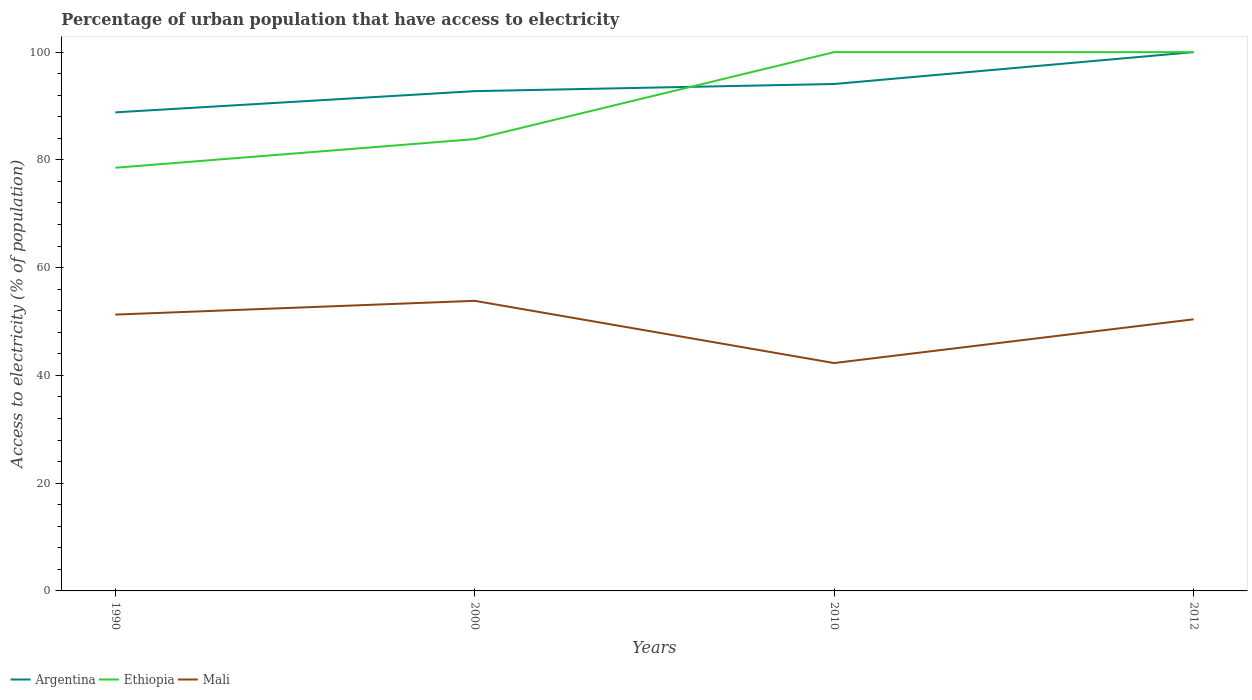Across all years, what is the maximum percentage of urban population that have access to electricity in Mali?
Provide a short and direct response. 42.29. What is the total percentage of urban population that have access to electricity in Argentina in the graph?
Give a very brief answer. -5.92. What is the difference between the highest and the second highest percentage of urban population that have access to electricity in Argentina?
Give a very brief answer. 11.18. What is the difference between the highest and the lowest percentage of urban population that have access to electricity in Mali?
Keep it short and to the point. 3. Where does the legend appear in the graph?
Your answer should be compact. Bottom left. How many legend labels are there?
Keep it short and to the point. 3. How are the legend labels stacked?
Your response must be concise. Horizontal. What is the title of the graph?
Provide a short and direct response. Percentage of urban population that have access to electricity. Does "Russian Federation" appear as one of the legend labels in the graph?
Offer a very short reply. No. What is the label or title of the Y-axis?
Offer a very short reply. Access to electricity (% of population). What is the Access to electricity (% of population) in Argentina in 1990?
Give a very brief answer. 88.82. What is the Access to electricity (% of population) in Ethiopia in 1990?
Provide a short and direct response. 78.54. What is the Access to electricity (% of population) in Mali in 1990?
Make the answer very short. 51.29. What is the Access to electricity (% of population) in Argentina in 2000?
Provide a succinct answer. 92.76. What is the Access to electricity (% of population) of Ethiopia in 2000?
Offer a very short reply. 83.85. What is the Access to electricity (% of population) in Mali in 2000?
Your answer should be compact. 53.84. What is the Access to electricity (% of population) in Argentina in 2010?
Make the answer very short. 94.08. What is the Access to electricity (% of population) of Ethiopia in 2010?
Provide a succinct answer. 100. What is the Access to electricity (% of population) in Mali in 2010?
Make the answer very short. 42.29. What is the Access to electricity (% of population) in Argentina in 2012?
Your response must be concise. 100. What is the Access to electricity (% of population) in Mali in 2012?
Make the answer very short. 50.41. Across all years, what is the maximum Access to electricity (% of population) of Mali?
Offer a terse response. 53.84. Across all years, what is the minimum Access to electricity (% of population) in Argentina?
Make the answer very short. 88.82. Across all years, what is the minimum Access to electricity (% of population) of Ethiopia?
Your response must be concise. 78.54. Across all years, what is the minimum Access to electricity (% of population) in Mali?
Keep it short and to the point. 42.29. What is the total Access to electricity (% of population) in Argentina in the graph?
Offer a terse response. 375.66. What is the total Access to electricity (% of population) in Ethiopia in the graph?
Ensure brevity in your answer.  362.39. What is the total Access to electricity (% of population) of Mali in the graph?
Provide a succinct answer. 197.83. What is the difference between the Access to electricity (% of population) of Argentina in 1990 and that in 2000?
Offer a terse response. -3.94. What is the difference between the Access to electricity (% of population) in Ethiopia in 1990 and that in 2000?
Provide a succinct answer. -5.31. What is the difference between the Access to electricity (% of population) of Mali in 1990 and that in 2000?
Keep it short and to the point. -2.56. What is the difference between the Access to electricity (% of population) in Argentina in 1990 and that in 2010?
Ensure brevity in your answer.  -5.26. What is the difference between the Access to electricity (% of population) of Ethiopia in 1990 and that in 2010?
Give a very brief answer. -21.46. What is the difference between the Access to electricity (% of population) of Mali in 1990 and that in 2010?
Your answer should be very brief. 8.99. What is the difference between the Access to electricity (% of population) of Argentina in 1990 and that in 2012?
Offer a terse response. -11.18. What is the difference between the Access to electricity (% of population) of Ethiopia in 1990 and that in 2012?
Your answer should be very brief. -21.46. What is the difference between the Access to electricity (% of population) of Mali in 1990 and that in 2012?
Offer a very short reply. 0.88. What is the difference between the Access to electricity (% of population) of Argentina in 2000 and that in 2010?
Keep it short and to the point. -1.32. What is the difference between the Access to electricity (% of population) of Ethiopia in 2000 and that in 2010?
Offer a very short reply. -16.15. What is the difference between the Access to electricity (% of population) in Mali in 2000 and that in 2010?
Make the answer very short. 11.55. What is the difference between the Access to electricity (% of population) of Argentina in 2000 and that in 2012?
Offer a very short reply. -7.24. What is the difference between the Access to electricity (% of population) of Ethiopia in 2000 and that in 2012?
Offer a terse response. -16.15. What is the difference between the Access to electricity (% of population) in Mali in 2000 and that in 2012?
Your response must be concise. 3.43. What is the difference between the Access to electricity (% of population) in Argentina in 2010 and that in 2012?
Provide a short and direct response. -5.92. What is the difference between the Access to electricity (% of population) in Ethiopia in 2010 and that in 2012?
Offer a very short reply. 0. What is the difference between the Access to electricity (% of population) in Mali in 2010 and that in 2012?
Keep it short and to the point. -8.12. What is the difference between the Access to electricity (% of population) of Argentina in 1990 and the Access to electricity (% of population) of Ethiopia in 2000?
Provide a succinct answer. 4.97. What is the difference between the Access to electricity (% of population) of Argentina in 1990 and the Access to electricity (% of population) of Mali in 2000?
Provide a short and direct response. 34.98. What is the difference between the Access to electricity (% of population) of Ethiopia in 1990 and the Access to electricity (% of population) of Mali in 2000?
Your answer should be compact. 24.7. What is the difference between the Access to electricity (% of population) in Argentina in 1990 and the Access to electricity (% of population) in Ethiopia in 2010?
Ensure brevity in your answer.  -11.18. What is the difference between the Access to electricity (% of population) in Argentina in 1990 and the Access to electricity (% of population) in Mali in 2010?
Provide a short and direct response. 46.53. What is the difference between the Access to electricity (% of population) in Ethiopia in 1990 and the Access to electricity (% of population) in Mali in 2010?
Keep it short and to the point. 36.25. What is the difference between the Access to electricity (% of population) in Argentina in 1990 and the Access to electricity (% of population) in Ethiopia in 2012?
Offer a very short reply. -11.18. What is the difference between the Access to electricity (% of population) of Argentina in 1990 and the Access to electricity (% of population) of Mali in 2012?
Offer a very short reply. 38.41. What is the difference between the Access to electricity (% of population) of Ethiopia in 1990 and the Access to electricity (% of population) of Mali in 2012?
Provide a succinct answer. 28.13. What is the difference between the Access to electricity (% of population) of Argentina in 2000 and the Access to electricity (% of population) of Ethiopia in 2010?
Make the answer very short. -7.24. What is the difference between the Access to electricity (% of population) in Argentina in 2000 and the Access to electricity (% of population) in Mali in 2010?
Your answer should be very brief. 50.47. What is the difference between the Access to electricity (% of population) of Ethiopia in 2000 and the Access to electricity (% of population) of Mali in 2010?
Give a very brief answer. 41.56. What is the difference between the Access to electricity (% of population) in Argentina in 2000 and the Access to electricity (% of population) in Ethiopia in 2012?
Offer a terse response. -7.24. What is the difference between the Access to electricity (% of population) in Argentina in 2000 and the Access to electricity (% of population) in Mali in 2012?
Keep it short and to the point. 42.35. What is the difference between the Access to electricity (% of population) of Ethiopia in 2000 and the Access to electricity (% of population) of Mali in 2012?
Ensure brevity in your answer.  33.44. What is the difference between the Access to electricity (% of population) of Argentina in 2010 and the Access to electricity (% of population) of Ethiopia in 2012?
Ensure brevity in your answer.  -5.92. What is the difference between the Access to electricity (% of population) of Argentina in 2010 and the Access to electricity (% of population) of Mali in 2012?
Provide a short and direct response. 43.67. What is the difference between the Access to electricity (% of population) in Ethiopia in 2010 and the Access to electricity (% of population) in Mali in 2012?
Provide a short and direct response. 49.59. What is the average Access to electricity (% of population) of Argentina per year?
Provide a short and direct response. 93.92. What is the average Access to electricity (% of population) in Ethiopia per year?
Keep it short and to the point. 90.6. What is the average Access to electricity (% of population) of Mali per year?
Keep it short and to the point. 49.46. In the year 1990, what is the difference between the Access to electricity (% of population) of Argentina and Access to electricity (% of population) of Ethiopia?
Provide a short and direct response. 10.28. In the year 1990, what is the difference between the Access to electricity (% of population) of Argentina and Access to electricity (% of population) of Mali?
Ensure brevity in your answer.  37.53. In the year 1990, what is the difference between the Access to electricity (% of population) in Ethiopia and Access to electricity (% of population) in Mali?
Offer a very short reply. 27.25. In the year 2000, what is the difference between the Access to electricity (% of population) of Argentina and Access to electricity (% of population) of Ethiopia?
Your response must be concise. 8.91. In the year 2000, what is the difference between the Access to electricity (% of population) in Argentina and Access to electricity (% of population) in Mali?
Your answer should be compact. 38.92. In the year 2000, what is the difference between the Access to electricity (% of population) in Ethiopia and Access to electricity (% of population) in Mali?
Make the answer very short. 30.01. In the year 2010, what is the difference between the Access to electricity (% of population) of Argentina and Access to electricity (% of population) of Ethiopia?
Make the answer very short. -5.92. In the year 2010, what is the difference between the Access to electricity (% of population) of Argentina and Access to electricity (% of population) of Mali?
Provide a succinct answer. 51.79. In the year 2010, what is the difference between the Access to electricity (% of population) in Ethiopia and Access to electricity (% of population) in Mali?
Provide a succinct answer. 57.71. In the year 2012, what is the difference between the Access to electricity (% of population) in Argentina and Access to electricity (% of population) in Ethiopia?
Ensure brevity in your answer.  0. In the year 2012, what is the difference between the Access to electricity (% of population) of Argentina and Access to electricity (% of population) of Mali?
Offer a terse response. 49.59. In the year 2012, what is the difference between the Access to electricity (% of population) in Ethiopia and Access to electricity (% of population) in Mali?
Keep it short and to the point. 49.59. What is the ratio of the Access to electricity (% of population) of Argentina in 1990 to that in 2000?
Offer a very short reply. 0.96. What is the ratio of the Access to electricity (% of population) in Ethiopia in 1990 to that in 2000?
Keep it short and to the point. 0.94. What is the ratio of the Access to electricity (% of population) in Mali in 1990 to that in 2000?
Give a very brief answer. 0.95. What is the ratio of the Access to electricity (% of population) of Argentina in 1990 to that in 2010?
Offer a very short reply. 0.94. What is the ratio of the Access to electricity (% of population) in Ethiopia in 1990 to that in 2010?
Offer a very short reply. 0.79. What is the ratio of the Access to electricity (% of population) of Mali in 1990 to that in 2010?
Keep it short and to the point. 1.21. What is the ratio of the Access to electricity (% of population) in Argentina in 1990 to that in 2012?
Keep it short and to the point. 0.89. What is the ratio of the Access to electricity (% of population) in Ethiopia in 1990 to that in 2012?
Your answer should be compact. 0.79. What is the ratio of the Access to electricity (% of population) of Mali in 1990 to that in 2012?
Provide a succinct answer. 1.02. What is the ratio of the Access to electricity (% of population) of Argentina in 2000 to that in 2010?
Offer a terse response. 0.99. What is the ratio of the Access to electricity (% of population) in Ethiopia in 2000 to that in 2010?
Offer a terse response. 0.84. What is the ratio of the Access to electricity (% of population) in Mali in 2000 to that in 2010?
Your answer should be compact. 1.27. What is the ratio of the Access to electricity (% of population) in Argentina in 2000 to that in 2012?
Provide a short and direct response. 0.93. What is the ratio of the Access to electricity (% of population) of Ethiopia in 2000 to that in 2012?
Offer a terse response. 0.84. What is the ratio of the Access to electricity (% of population) of Mali in 2000 to that in 2012?
Provide a short and direct response. 1.07. What is the ratio of the Access to electricity (% of population) of Argentina in 2010 to that in 2012?
Give a very brief answer. 0.94. What is the ratio of the Access to electricity (% of population) in Ethiopia in 2010 to that in 2012?
Make the answer very short. 1. What is the ratio of the Access to electricity (% of population) of Mali in 2010 to that in 2012?
Provide a short and direct response. 0.84. What is the difference between the highest and the second highest Access to electricity (% of population) in Argentina?
Offer a terse response. 5.92. What is the difference between the highest and the second highest Access to electricity (% of population) in Mali?
Provide a short and direct response. 2.56. What is the difference between the highest and the lowest Access to electricity (% of population) in Argentina?
Make the answer very short. 11.18. What is the difference between the highest and the lowest Access to electricity (% of population) in Ethiopia?
Provide a succinct answer. 21.46. What is the difference between the highest and the lowest Access to electricity (% of population) in Mali?
Your answer should be compact. 11.55. 